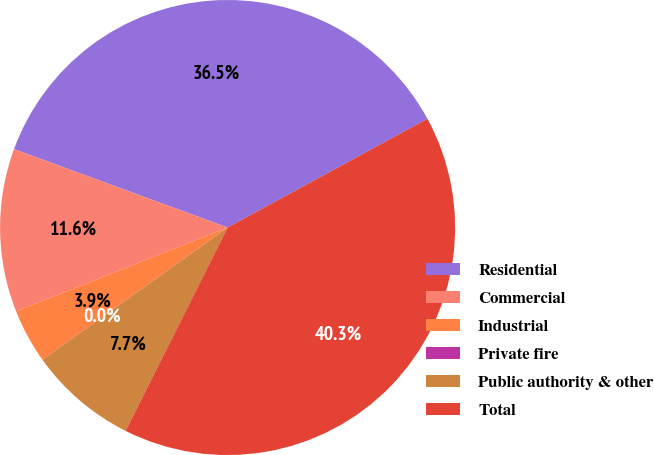Convert chart to OTSL. <chart><loc_0><loc_0><loc_500><loc_500><pie_chart><fcel>Residential<fcel>Commercial<fcel>Industrial<fcel>Private fire<fcel>Public authority & other<fcel>Total<nl><fcel>36.47%<fcel>11.6%<fcel>3.87%<fcel>0.0%<fcel>7.73%<fcel>40.33%<nl></chart> 